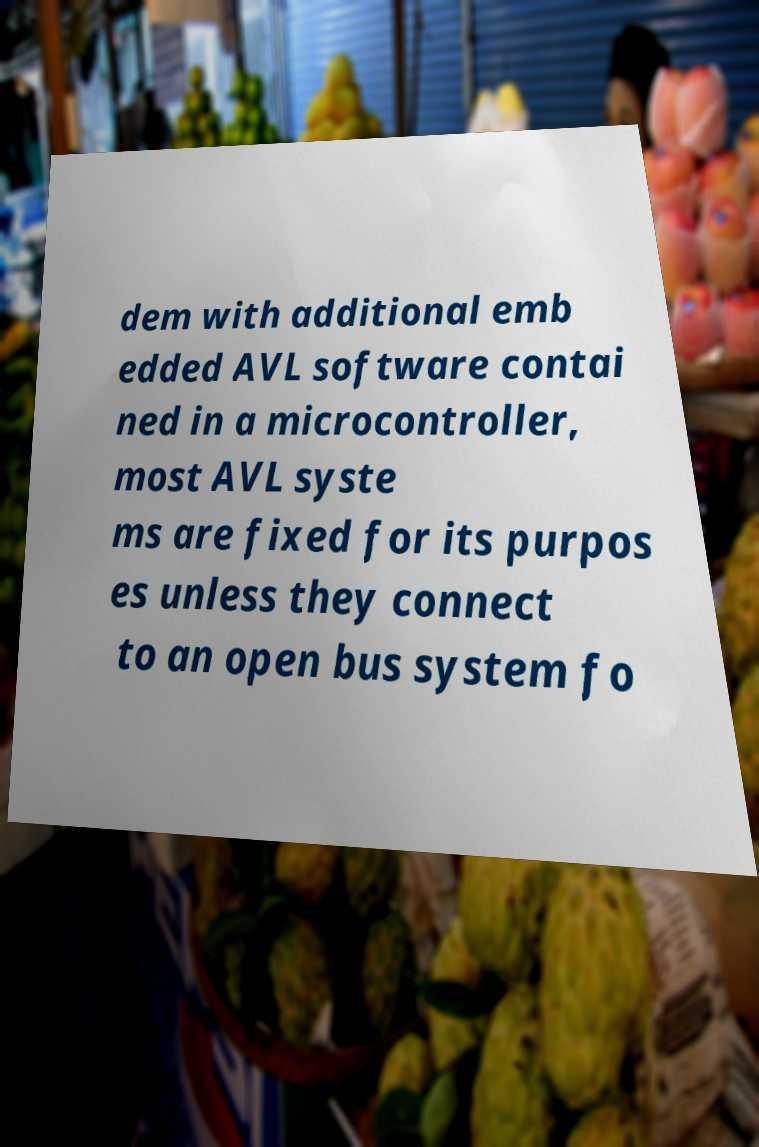There's text embedded in this image that I need extracted. Can you transcribe it verbatim? dem with additional emb edded AVL software contai ned in a microcontroller, most AVL syste ms are fixed for its purpos es unless they connect to an open bus system fo 